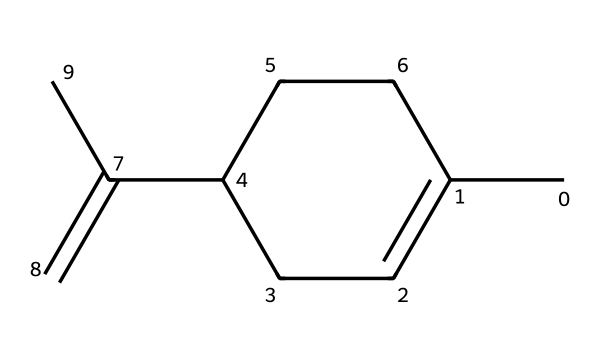What is the name of this chemical? The SMILES representation corresponds to limonene, which is known for its characteristic citrus scent.
Answer: limonene How many carbon atoms are in limonene? By analyzing the SMILES structure, we count 10 carbon atoms represented by "C".
Answer: 10 What type of smell does limonene produce? Limonene produces a citrus scent, commonly associated with oranges and lemons in cleaning products.
Answer: citrus How many double bonds are in the limonene structure? Observing the SMILES, we see there are two double bonds (C=C) that signify the presence of unsaturation.
Answer: 2 What functional group is primarily responsible for limonene's aroma? The presence of the alkene functional group (due to C=C double bonds) is primarily responsible for the aromatic characteristics of limonene.
Answer: alkene Is limonene a saturated or unsaturated hydrocarbon? The presence of double bonds in the structure indicates that limonene is an unsaturated hydrocarbon.
Answer: unsaturated What is the main use of limonene in products? Limonene is primarily used as a flavoring and fragrance agent in cleaning products and cosmetics due to its pleasant scent.
Answer: fragrance 